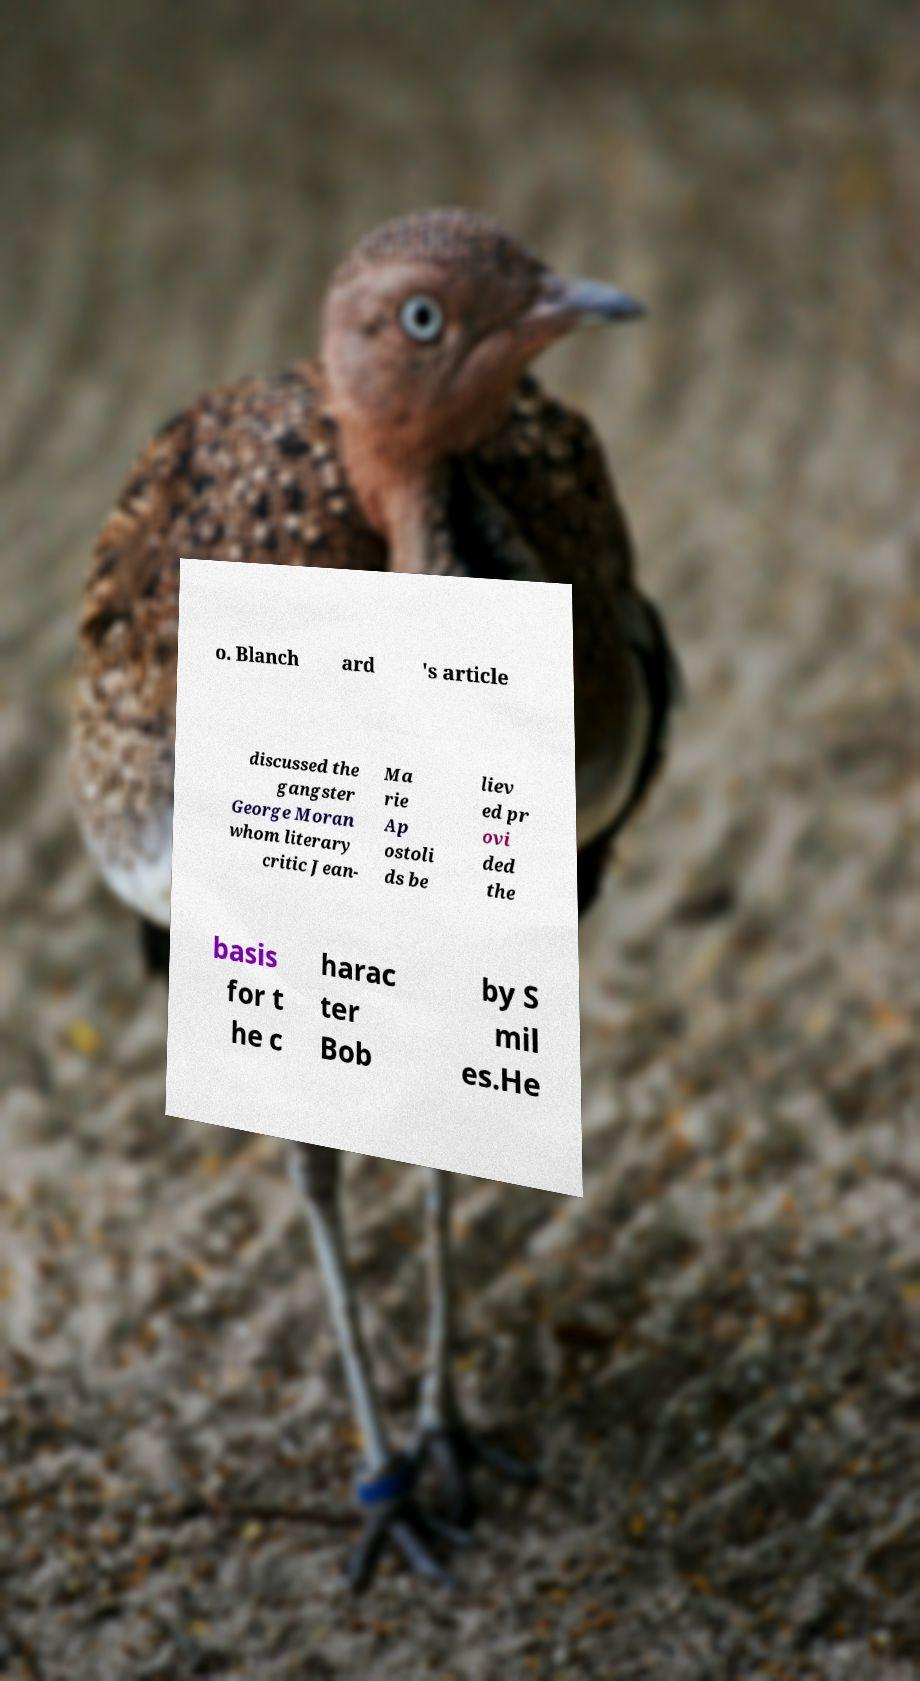Could you extract and type out the text from this image? o. Blanch ard 's article discussed the gangster George Moran whom literary critic Jean- Ma rie Ap ostoli ds be liev ed pr ovi ded the basis for t he c harac ter Bob by S mil es.He 